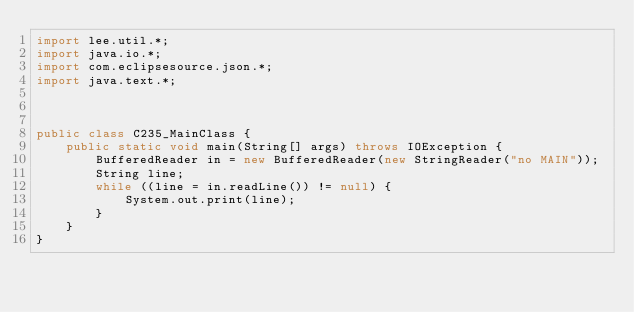<code> <loc_0><loc_0><loc_500><loc_500><_Java_>import lee.util.*;
import java.io.*;
import com.eclipsesource.json.*;
import java.text.*;



public class C235_MainClass {
    public static void main(String[] args) throws IOException {
        BufferedReader in = new BufferedReader(new StringReader("no MAIN"));
        String line;
        while ((line = in.readLine()) != null) {
            System.out.print(line);
        }
    }
}                                    
                                    </code> 